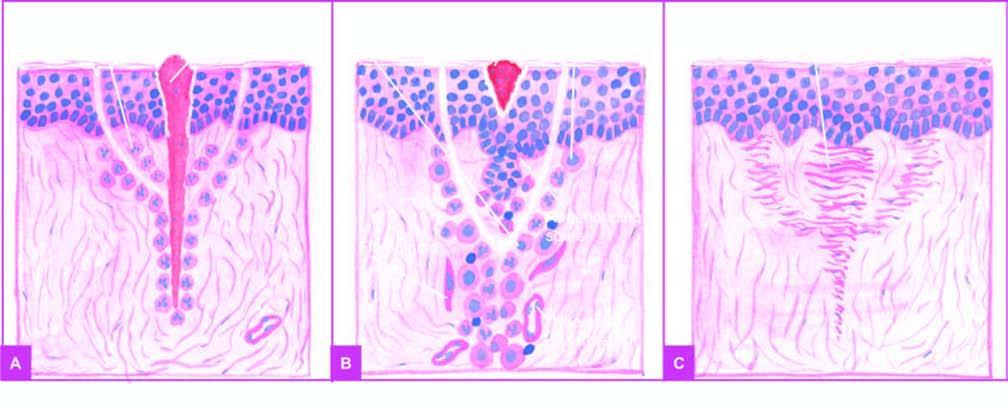s there inflammatory response from the margins?
Answer the question using a single word or phrase. Yes 